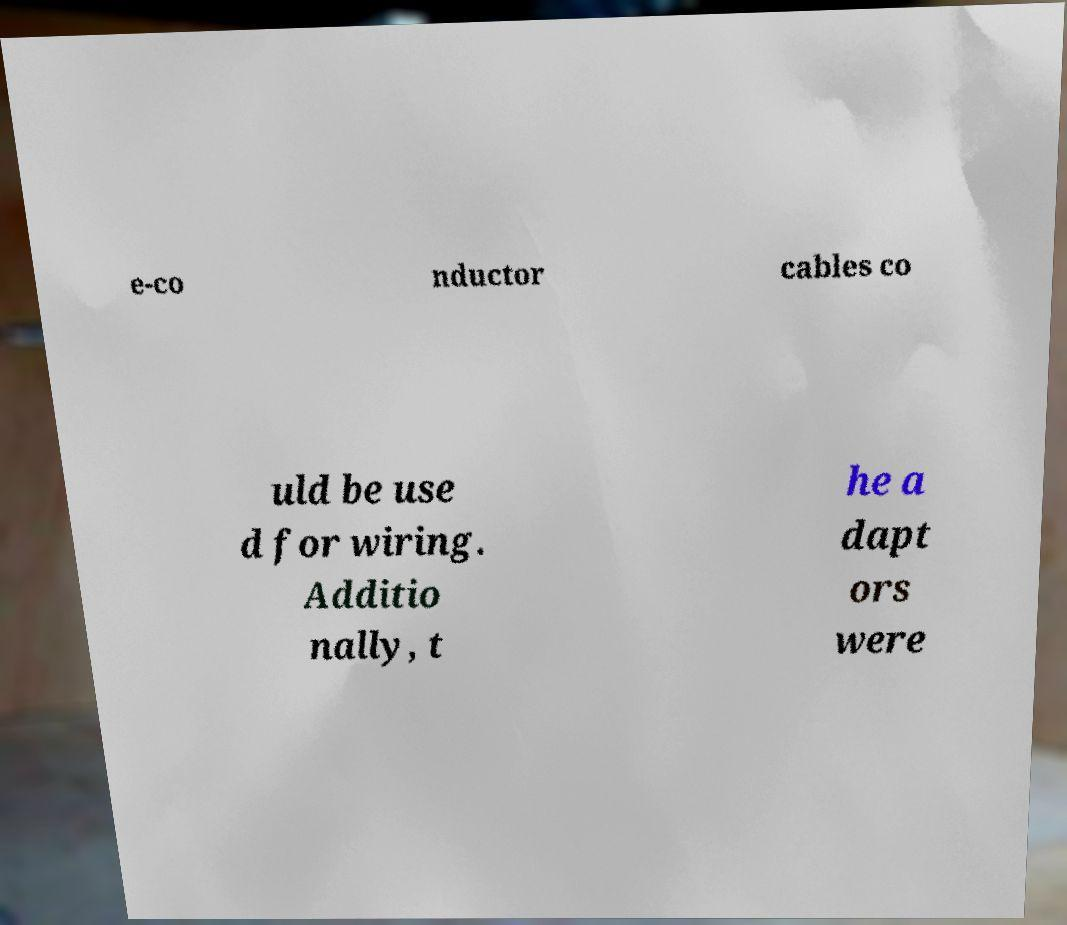What messages or text are displayed in this image? I need them in a readable, typed format. e-co nductor cables co uld be use d for wiring. Additio nally, t he a dapt ors were 